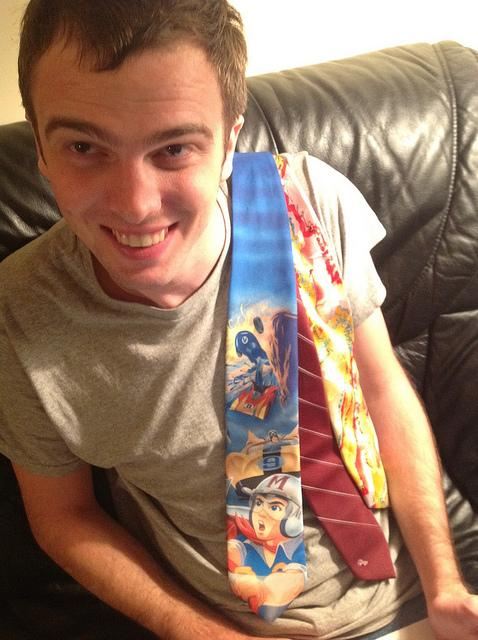What clothing item does the man have most of? ties 